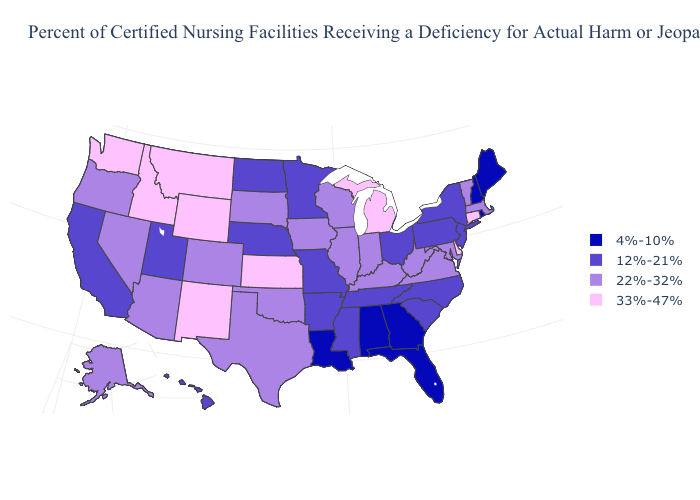What is the value of South Carolina?
Keep it brief. 12%-21%. What is the value of South Dakota?
Keep it brief. 22%-32%. Which states hav the highest value in the South?
Keep it brief. Delaware. Name the states that have a value in the range 12%-21%?
Answer briefly. Arkansas, California, Hawaii, Minnesota, Mississippi, Missouri, Nebraska, New Jersey, New York, North Carolina, North Dakota, Ohio, Pennsylvania, South Carolina, Tennessee, Utah. What is the value of Kentucky?
Be succinct. 22%-32%. What is the value of Nevada?
Give a very brief answer. 22%-32%. Does Connecticut have the highest value in the USA?
Answer briefly. Yes. What is the value of South Carolina?
Concise answer only. 12%-21%. Name the states that have a value in the range 33%-47%?
Keep it brief. Connecticut, Delaware, Idaho, Kansas, Michigan, Montana, New Mexico, Washington, Wyoming. What is the highest value in the USA?
Concise answer only. 33%-47%. Name the states that have a value in the range 33%-47%?
Be succinct. Connecticut, Delaware, Idaho, Kansas, Michigan, Montana, New Mexico, Washington, Wyoming. Among the states that border Vermont , does New York have the highest value?
Write a very short answer. No. What is the value of Connecticut?
Concise answer only. 33%-47%. Name the states that have a value in the range 4%-10%?
Quick response, please. Alabama, Florida, Georgia, Louisiana, Maine, New Hampshire, Rhode Island. Does the map have missing data?
Short answer required. No. 